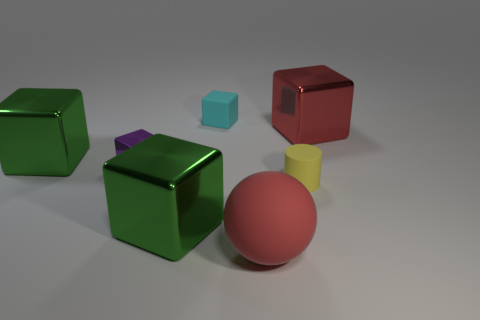Are there more large green cubes in front of the matte ball than small shiny blocks?
Provide a succinct answer. No. Is the shape of the big green object that is in front of the tiny yellow rubber thing the same as  the small metal object?
Offer a terse response. Yes. Are there any metallic things of the same shape as the big red matte thing?
Give a very brief answer. No. What number of things are small objects that are left of the small cyan thing or gray metal blocks?
Your answer should be compact. 1. Is the number of large matte spheres greater than the number of tiny gray metal objects?
Your response must be concise. Yes. Are there any cyan blocks of the same size as the purple object?
Make the answer very short. Yes. What number of things are metallic things that are to the left of the rubber sphere or matte things that are behind the small yellow matte thing?
Make the answer very short. 4. There is a block to the right of the red object that is left of the large red cube; what color is it?
Provide a succinct answer. Red. What is the color of the small cylinder that is made of the same material as the ball?
Give a very brief answer. Yellow. What number of small matte cylinders are the same color as the small rubber cube?
Your response must be concise. 0. 